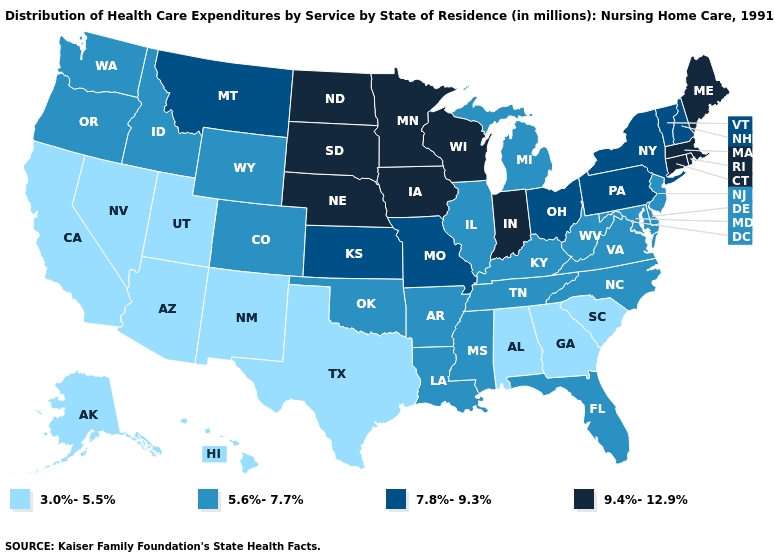Name the states that have a value in the range 5.6%-7.7%?
Concise answer only. Arkansas, Colorado, Delaware, Florida, Idaho, Illinois, Kentucky, Louisiana, Maryland, Michigan, Mississippi, New Jersey, North Carolina, Oklahoma, Oregon, Tennessee, Virginia, Washington, West Virginia, Wyoming. What is the highest value in states that border Connecticut?
Short answer required. 9.4%-12.9%. Among the states that border Missouri , does Kentucky have the lowest value?
Keep it brief. Yes. Name the states that have a value in the range 3.0%-5.5%?
Answer briefly. Alabama, Alaska, Arizona, California, Georgia, Hawaii, Nevada, New Mexico, South Carolina, Texas, Utah. What is the value of South Carolina?
Quick response, please. 3.0%-5.5%. What is the lowest value in the South?
Quick response, please. 3.0%-5.5%. Does Alabama have a higher value than Rhode Island?
Write a very short answer. No. Among the states that border Arkansas , which have the highest value?
Concise answer only. Missouri. Which states have the lowest value in the USA?
Answer briefly. Alabama, Alaska, Arizona, California, Georgia, Hawaii, Nevada, New Mexico, South Carolina, Texas, Utah. Name the states that have a value in the range 7.8%-9.3%?
Write a very short answer. Kansas, Missouri, Montana, New Hampshire, New York, Ohio, Pennsylvania, Vermont. Does the first symbol in the legend represent the smallest category?
Quick response, please. Yes. Does Connecticut have the same value as Iowa?
Give a very brief answer. Yes. Does the first symbol in the legend represent the smallest category?
Short answer required. Yes. Does Montana have the highest value in the West?
Answer briefly. Yes. What is the value of Maine?
Keep it brief. 9.4%-12.9%. 